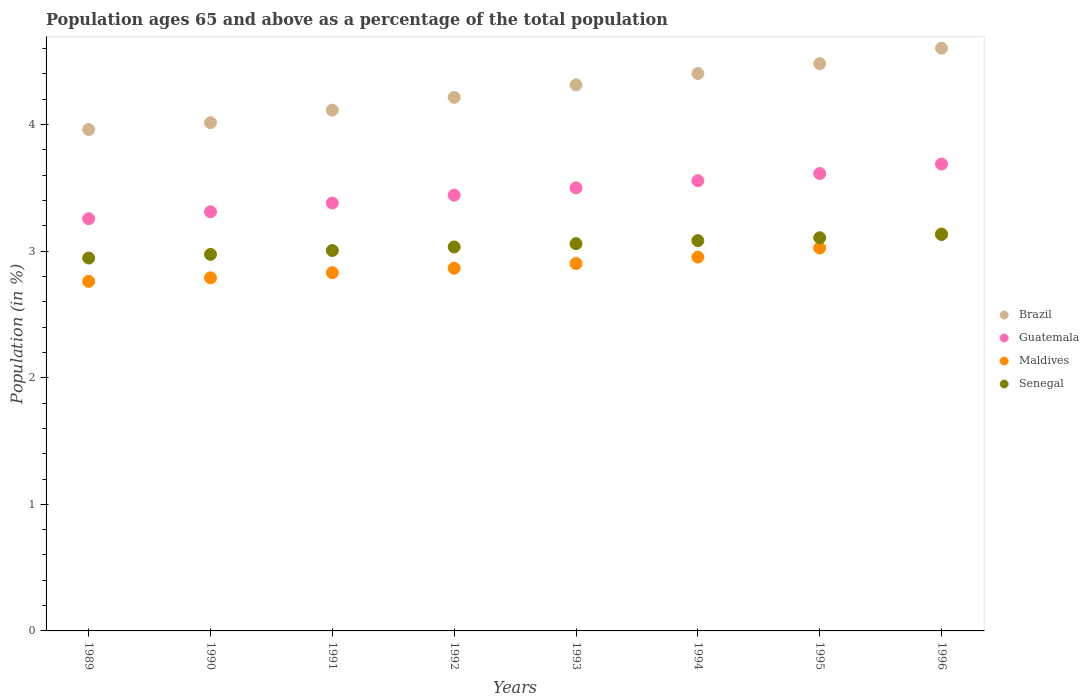Is the number of dotlines equal to the number of legend labels?
Offer a terse response. Yes. What is the percentage of the population ages 65 and above in Senegal in 1996?
Ensure brevity in your answer.  3.13. Across all years, what is the maximum percentage of the population ages 65 and above in Guatemala?
Ensure brevity in your answer.  3.69. Across all years, what is the minimum percentage of the population ages 65 and above in Brazil?
Ensure brevity in your answer.  3.96. What is the total percentage of the population ages 65 and above in Maldives in the graph?
Keep it short and to the point. 23.26. What is the difference between the percentage of the population ages 65 and above in Senegal in 1989 and that in 1991?
Offer a very short reply. -0.06. What is the difference between the percentage of the population ages 65 and above in Brazil in 1992 and the percentage of the population ages 65 and above in Senegal in 1995?
Give a very brief answer. 1.11. What is the average percentage of the population ages 65 and above in Guatemala per year?
Offer a very short reply. 3.47. In the year 1996, what is the difference between the percentage of the population ages 65 and above in Maldives and percentage of the population ages 65 and above in Brazil?
Provide a succinct answer. -1.47. In how many years, is the percentage of the population ages 65 and above in Guatemala greater than 0.8?
Your answer should be very brief. 8. What is the ratio of the percentage of the population ages 65 and above in Maldives in 1991 to that in 1993?
Your answer should be very brief. 0.98. Is the difference between the percentage of the population ages 65 and above in Maldives in 1993 and 1994 greater than the difference between the percentage of the population ages 65 and above in Brazil in 1993 and 1994?
Offer a terse response. Yes. What is the difference between the highest and the second highest percentage of the population ages 65 and above in Senegal?
Keep it short and to the point. 0.03. What is the difference between the highest and the lowest percentage of the population ages 65 and above in Maldives?
Give a very brief answer. 0.37. Is it the case that in every year, the sum of the percentage of the population ages 65 and above in Senegal and percentage of the population ages 65 and above in Maldives  is greater than the sum of percentage of the population ages 65 and above in Brazil and percentage of the population ages 65 and above in Guatemala?
Offer a terse response. No. Does the percentage of the population ages 65 and above in Guatemala monotonically increase over the years?
Provide a short and direct response. Yes. Is the percentage of the population ages 65 and above in Guatemala strictly greater than the percentage of the population ages 65 and above in Senegal over the years?
Provide a short and direct response. Yes. Does the graph contain any zero values?
Your answer should be very brief. No. Does the graph contain grids?
Your answer should be very brief. No. Where does the legend appear in the graph?
Ensure brevity in your answer.  Center right. What is the title of the graph?
Provide a succinct answer. Population ages 65 and above as a percentage of the total population. What is the label or title of the X-axis?
Your answer should be compact. Years. What is the label or title of the Y-axis?
Offer a very short reply. Population (in %). What is the Population (in %) of Brazil in 1989?
Offer a terse response. 3.96. What is the Population (in %) of Guatemala in 1989?
Your response must be concise. 3.26. What is the Population (in %) of Maldives in 1989?
Your answer should be very brief. 2.76. What is the Population (in %) in Senegal in 1989?
Give a very brief answer. 2.95. What is the Population (in %) in Brazil in 1990?
Your answer should be compact. 4.02. What is the Population (in %) in Guatemala in 1990?
Offer a very short reply. 3.31. What is the Population (in %) in Maldives in 1990?
Offer a terse response. 2.79. What is the Population (in %) of Senegal in 1990?
Give a very brief answer. 2.97. What is the Population (in %) in Brazil in 1991?
Make the answer very short. 4.11. What is the Population (in %) in Guatemala in 1991?
Your answer should be very brief. 3.38. What is the Population (in %) of Maldives in 1991?
Make the answer very short. 2.83. What is the Population (in %) of Senegal in 1991?
Your answer should be very brief. 3.01. What is the Population (in %) of Brazil in 1992?
Make the answer very short. 4.21. What is the Population (in %) of Guatemala in 1992?
Provide a succinct answer. 3.44. What is the Population (in %) in Maldives in 1992?
Your answer should be very brief. 2.87. What is the Population (in %) of Senegal in 1992?
Your response must be concise. 3.03. What is the Population (in %) in Brazil in 1993?
Offer a terse response. 4.31. What is the Population (in %) of Guatemala in 1993?
Provide a short and direct response. 3.5. What is the Population (in %) in Maldives in 1993?
Offer a terse response. 2.9. What is the Population (in %) in Senegal in 1993?
Provide a short and direct response. 3.06. What is the Population (in %) of Brazil in 1994?
Provide a succinct answer. 4.4. What is the Population (in %) of Guatemala in 1994?
Ensure brevity in your answer.  3.56. What is the Population (in %) in Maldives in 1994?
Your answer should be compact. 2.95. What is the Population (in %) of Senegal in 1994?
Give a very brief answer. 3.08. What is the Population (in %) in Brazil in 1995?
Provide a short and direct response. 4.48. What is the Population (in %) of Guatemala in 1995?
Ensure brevity in your answer.  3.61. What is the Population (in %) of Maldives in 1995?
Offer a terse response. 3.02. What is the Population (in %) in Senegal in 1995?
Provide a succinct answer. 3.11. What is the Population (in %) of Brazil in 1996?
Offer a very short reply. 4.6. What is the Population (in %) of Guatemala in 1996?
Ensure brevity in your answer.  3.69. What is the Population (in %) in Maldives in 1996?
Offer a very short reply. 3.14. What is the Population (in %) of Senegal in 1996?
Your response must be concise. 3.13. Across all years, what is the maximum Population (in %) in Brazil?
Your response must be concise. 4.6. Across all years, what is the maximum Population (in %) in Guatemala?
Your response must be concise. 3.69. Across all years, what is the maximum Population (in %) of Maldives?
Your answer should be compact. 3.14. Across all years, what is the maximum Population (in %) of Senegal?
Give a very brief answer. 3.13. Across all years, what is the minimum Population (in %) of Brazil?
Give a very brief answer. 3.96. Across all years, what is the minimum Population (in %) of Guatemala?
Give a very brief answer. 3.26. Across all years, what is the minimum Population (in %) of Maldives?
Your response must be concise. 2.76. Across all years, what is the minimum Population (in %) of Senegal?
Offer a very short reply. 2.95. What is the total Population (in %) in Brazil in the graph?
Offer a terse response. 34.11. What is the total Population (in %) in Guatemala in the graph?
Your answer should be compact. 27.75. What is the total Population (in %) in Maldives in the graph?
Make the answer very short. 23.26. What is the total Population (in %) in Senegal in the graph?
Make the answer very short. 24.34. What is the difference between the Population (in %) in Brazil in 1989 and that in 1990?
Your answer should be compact. -0.05. What is the difference between the Population (in %) in Guatemala in 1989 and that in 1990?
Your answer should be compact. -0.05. What is the difference between the Population (in %) of Maldives in 1989 and that in 1990?
Offer a very short reply. -0.03. What is the difference between the Population (in %) in Senegal in 1989 and that in 1990?
Make the answer very short. -0.03. What is the difference between the Population (in %) in Brazil in 1989 and that in 1991?
Your answer should be very brief. -0.15. What is the difference between the Population (in %) in Guatemala in 1989 and that in 1991?
Your response must be concise. -0.12. What is the difference between the Population (in %) in Maldives in 1989 and that in 1991?
Provide a short and direct response. -0.07. What is the difference between the Population (in %) of Senegal in 1989 and that in 1991?
Your response must be concise. -0.06. What is the difference between the Population (in %) of Brazil in 1989 and that in 1992?
Offer a very short reply. -0.25. What is the difference between the Population (in %) of Guatemala in 1989 and that in 1992?
Your answer should be very brief. -0.19. What is the difference between the Population (in %) in Maldives in 1989 and that in 1992?
Keep it short and to the point. -0.1. What is the difference between the Population (in %) of Senegal in 1989 and that in 1992?
Your response must be concise. -0.09. What is the difference between the Population (in %) in Brazil in 1989 and that in 1993?
Your response must be concise. -0.35. What is the difference between the Population (in %) of Guatemala in 1989 and that in 1993?
Your answer should be very brief. -0.24. What is the difference between the Population (in %) in Maldives in 1989 and that in 1993?
Make the answer very short. -0.14. What is the difference between the Population (in %) in Senegal in 1989 and that in 1993?
Your response must be concise. -0.11. What is the difference between the Population (in %) in Brazil in 1989 and that in 1994?
Provide a short and direct response. -0.44. What is the difference between the Population (in %) of Guatemala in 1989 and that in 1994?
Offer a terse response. -0.3. What is the difference between the Population (in %) of Maldives in 1989 and that in 1994?
Ensure brevity in your answer.  -0.19. What is the difference between the Population (in %) of Senegal in 1989 and that in 1994?
Provide a succinct answer. -0.14. What is the difference between the Population (in %) of Brazil in 1989 and that in 1995?
Give a very brief answer. -0.52. What is the difference between the Population (in %) in Guatemala in 1989 and that in 1995?
Your response must be concise. -0.36. What is the difference between the Population (in %) of Maldives in 1989 and that in 1995?
Offer a terse response. -0.26. What is the difference between the Population (in %) in Senegal in 1989 and that in 1995?
Your answer should be very brief. -0.16. What is the difference between the Population (in %) of Brazil in 1989 and that in 1996?
Your response must be concise. -0.64. What is the difference between the Population (in %) of Guatemala in 1989 and that in 1996?
Provide a succinct answer. -0.43. What is the difference between the Population (in %) in Maldives in 1989 and that in 1996?
Your answer should be very brief. -0.37. What is the difference between the Population (in %) of Senegal in 1989 and that in 1996?
Offer a terse response. -0.19. What is the difference between the Population (in %) of Brazil in 1990 and that in 1991?
Your answer should be very brief. -0.1. What is the difference between the Population (in %) in Guatemala in 1990 and that in 1991?
Offer a terse response. -0.07. What is the difference between the Population (in %) of Maldives in 1990 and that in 1991?
Give a very brief answer. -0.04. What is the difference between the Population (in %) in Senegal in 1990 and that in 1991?
Provide a succinct answer. -0.03. What is the difference between the Population (in %) in Brazil in 1990 and that in 1992?
Offer a very short reply. -0.2. What is the difference between the Population (in %) of Guatemala in 1990 and that in 1992?
Ensure brevity in your answer.  -0.13. What is the difference between the Population (in %) of Maldives in 1990 and that in 1992?
Offer a terse response. -0.08. What is the difference between the Population (in %) of Senegal in 1990 and that in 1992?
Make the answer very short. -0.06. What is the difference between the Population (in %) in Brazil in 1990 and that in 1993?
Provide a succinct answer. -0.3. What is the difference between the Population (in %) of Guatemala in 1990 and that in 1993?
Give a very brief answer. -0.19. What is the difference between the Population (in %) of Maldives in 1990 and that in 1993?
Ensure brevity in your answer.  -0.11. What is the difference between the Population (in %) of Senegal in 1990 and that in 1993?
Offer a very short reply. -0.08. What is the difference between the Population (in %) of Brazil in 1990 and that in 1994?
Your answer should be very brief. -0.39. What is the difference between the Population (in %) in Guatemala in 1990 and that in 1994?
Offer a very short reply. -0.24. What is the difference between the Population (in %) in Maldives in 1990 and that in 1994?
Keep it short and to the point. -0.16. What is the difference between the Population (in %) in Senegal in 1990 and that in 1994?
Offer a very short reply. -0.11. What is the difference between the Population (in %) in Brazil in 1990 and that in 1995?
Your answer should be very brief. -0.47. What is the difference between the Population (in %) of Guatemala in 1990 and that in 1995?
Provide a succinct answer. -0.3. What is the difference between the Population (in %) in Maldives in 1990 and that in 1995?
Give a very brief answer. -0.24. What is the difference between the Population (in %) of Senegal in 1990 and that in 1995?
Your response must be concise. -0.13. What is the difference between the Population (in %) in Brazil in 1990 and that in 1996?
Ensure brevity in your answer.  -0.59. What is the difference between the Population (in %) of Guatemala in 1990 and that in 1996?
Your answer should be compact. -0.38. What is the difference between the Population (in %) in Maldives in 1990 and that in 1996?
Ensure brevity in your answer.  -0.35. What is the difference between the Population (in %) in Senegal in 1990 and that in 1996?
Provide a succinct answer. -0.16. What is the difference between the Population (in %) in Brazil in 1991 and that in 1992?
Keep it short and to the point. -0.1. What is the difference between the Population (in %) of Guatemala in 1991 and that in 1992?
Provide a short and direct response. -0.06. What is the difference between the Population (in %) of Maldives in 1991 and that in 1992?
Ensure brevity in your answer.  -0.04. What is the difference between the Population (in %) of Senegal in 1991 and that in 1992?
Your answer should be very brief. -0.03. What is the difference between the Population (in %) in Brazil in 1991 and that in 1993?
Make the answer very short. -0.2. What is the difference between the Population (in %) in Guatemala in 1991 and that in 1993?
Your answer should be very brief. -0.12. What is the difference between the Population (in %) in Maldives in 1991 and that in 1993?
Your answer should be compact. -0.07. What is the difference between the Population (in %) of Senegal in 1991 and that in 1993?
Give a very brief answer. -0.05. What is the difference between the Population (in %) of Brazil in 1991 and that in 1994?
Offer a very short reply. -0.29. What is the difference between the Population (in %) in Guatemala in 1991 and that in 1994?
Make the answer very short. -0.18. What is the difference between the Population (in %) of Maldives in 1991 and that in 1994?
Give a very brief answer. -0.12. What is the difference between the Population (in %) of Senegal in 1991 and that in 1994?
Provide a succinct answer. -0.08. What is the difference between the Population (in %) in Brazil in 1991 and that in 1995?
Offer a very short reply. -0.37. What is the difference between the Population (in %) of Guatemala in 1991 and that in 1995?
Offer a very short reply. -0.23. What is the difference between the Population (in %) of Maldives in 1991 and that in 1995?
Make the answer very short. -0.19. What is the difference between the Population (in %) in Senegal in 1991 and that in 1995?
Offer a very short reply. -0.1. What is the difference between the Population (in %) of Brazil in 1991 and that in 1996?
Your response must be concise. -0.49. What is the difference between the Population (in %) of Guatemala in 1991 and that in 1996?
Your response must be concise. -0.31. What is the difference between the Population (in %) in Maldives in 1991 and that in 1996?
Keep it short and to the point. -0.31. What is the difference between the Population (in %) of Senegal in 1991 and that in 1996?
Your answer should be compact. -0.13. What is the difference between the Population (in %) in Brazil in 1992 and that in 1993?
Provide a succinct answer. -0.1. What is the difference between the Population (in %) of Guatemala in 1992 and that in 1993?
Your answer should be very brief. -0.06. What is the difference between the Population (in %) in Maldives in 1992 and that in 1993?
Your response must be concise. -0.04. What is the difference between the Population (in %) of Senegal in 1992 and that in 1993?
Offer a terse response. -0.03. What is the difference between the Population (in %) in Brazil in 1992 and that in 1994?
Keep it short and to the point. -0.19. What is the difference between the Population (in %) of Guatemala in 1992 and that in 1994?
Ensure brevity in your answer.  -0.11. What is the difference between the Population (in %) of Maldives in 1992 and that in 1994?
Ensure brevity in your answer.  -0.09. What is the difference between the Population (in %) in Senegal in 1992 and that in 1994?
Your answer should be compact. -0.05. What is the difference between the Population (in %) of Brazil in 1992 and that in 1995?
Provide a succinct answer. -0.27. What is the difference between the Population (in %) of Guatemala in 1992 and that in 1995?
Offer a terse response. -0.17. What is the difference between the Population (in %) of Maldives in 1992 and that in 1995?
Give a very brief answer. -0.16. What is the difference between the Population (in %) of Senegal in 1992 and that in 1995?
Offer a very short reply. -0.07. What is the difference between the Population (in %) of Brazil in 1992 and that in 1996?
Provide a short and direct response. -0.39. What is the difference between the Population (in %) of Guatemala in 1992 and that in 1996?
Provide a short and direct response. -0.25. What is the difference between the Population (in %) in Maldives in 1992 and that in 1996?
Offer a very short reply. -0.27. What is the difference between the Population (in %) in Senegal in 1992 and that in 1996?
Your answer should be very brief. -0.1. What is the difference between the Population (in %) of Brazil in 1993 and that in 1994?
Your response must be concise. -0.09. What is the difference between the Population (in %) in Guatemala in 1993 and that in 1994?
Your answer should be very brief. -0.06. What is the difference between the Population (in %) of Maldives in 1993 and that in 1994?
Offer a very short reply. -0.05. What is the difference between the Population (in %) in Senegal in 1993 and that in 1994?
Give a very brief answer. -0.02. What is the difference between the Population (in %) of Brazil in 1993 and that in 1995?
Your response must be concise. -0.17. What is the difference between the Population (in %) of Guatemala in 1993 and that in 1995?
Provide a short and direct response. -0.11. What is the difference between the Population (in %) of Maldives in 1993 and that in 1995?
Ensure brevity in your answer.  -0.12. What is the difference between the Population (in %) in Senegal in 1993 and that in 1995?
Give a very brief answer. -0.05. What is the difference between the Population (in %) in Brazil in 1993 and that in 1996?
Your answer should be very brief. -0.29. What is the difference between the Population (in %) in Guatemala in 1993 and that in 1996?
Your answer should be compact. -0.19. What is the difference between the Population (in %) of Maldives in 1993 and that in 1996?
Ensure brevity in your answer.  -0.23. What is the difference between the Population (in %) in Senegal in 1993 and that in 1996?
Offer a very short reply. -0.07. What is the difference between the Population (in %) in Brazil in 1994 and that in 1995?
Ensure brevity in your answer.  -0.08. What is the difference between the Population (in %) of Guatemala in 1994 and that in 1995?
Make the answer very short. -0.06. What is the difference between the Population (in %) in Maldives in 1994 and that in 1995?
Your answer should be very brief. -0.07. What is the difference between the Population (in %) of Senegal in 1994 and that in 1995?
Give a very brief answer. -0.02. What is the difference between the Population (in %) in Brazil in 1994 and that in 1996?
Make the answer very short. -0.2. What is the difference between the Population (in %) in Guatemala in 1994 and that in 1996?
Your answer should be very brief. -0.13. What is the difference between the Population (in %) of Maldives in 1994 and that in 1996?
Your answer should be compact. -0.18. What is the difference between the Population (in %) of Senegal in 1994 and that in 1996?
Give a very brief answer. -0.05. What is the difference between the Population (in %) of Brazil in 1995 and that in 1996?
Keep it short and to the point. -0.12. What is the difference between the Population (in %) of Guatemala in 1995 and that in 1996?
Keep it short and to the point. -0.07. What is the difference between the Population (in %) in Maldives in 1995 and that in 1996?
Offer a terse response. -0.11. What is the difference between the Population (in %) in Senegal in 1995 and that in 1996?
Provide a succinct answer. -0.03. What is the difference between the Population (in %) in Brazil in 1989 and the Population (in %) in Guatemala in 1990?
Your answer should be compact. 0.65. What is the difference between the Population (in %) in Brazil in 1989 and the Population (in %) in Maldives in 1990?
Provide a short and direct response. 1.17. What is the difference between the Population (in %) in Brazil in 1989 and the Population (in %) in Senegal in 1990?
Offer a very short reply. 0.99. What is the difference between the Population (in %) of Guatemala in 1989 and the Population (in %) of Maldives in 1990?
Offer a very short reply. 0.47. What is the difference between the Population (in %) of Guatemala in 1989 and the Population (in %) of Senegal in 1990?
Your answer should be very brief. 0.28. What is the difference between the Population (in %) in Maldives in 1989 and the Population (in %) in Senegal in 1990?
Provide a short and direct response. -0.21. What is the difference between the Population (in %) in Brazil in 1989 and the Population (in %) in Guatemala in 1991?
Keep it short and to the point. 0.58. What is the difference between the Population (in %) of Brazil in 1989 and the Population (in %) of Maldives in 1991?
Your response must be concise. 1.13. What is the difference between the Population (in %) in Brazil in 1989 and the Population (in %) in Senegal in 1991?
Provide a succinct answer. 0.96. What is the difference between the Population (in %) in Guatemala in 1989 and the Population (in %) in Maldives in 1991?
Your answer should be compact. 0.43. What is the difference between the Population (in %) of Guatemala in 1989 and the Population (in %) of Senegal in 1991?
Make the answer very short. 0.25. What is the difference between the Population (in %) of Maldives in 1989 and the Population (in %) of Senegal in 1991?
Your response must be concise. -0.24. What is the difference between the Population (in %) in Brazil in 1989 and the Population (in %) in Guatemala in 1992?
Make the answer very short. 0.52. What is the difference between the Population (in %) in Brazil in 1989 and the Population (in %) in Maldives in 1992?
Your answer should be very brief. 1.1. What is the difference between the Population (in %) of Brazil in 1989 and the Population (in %) of Senegal in 1992?
Your response must be concise. 0.93. What is the difference between the Population (in %) in Guatemala in 1989 and the Population (in %) in Maldives in 1992?
Provide a succinct answer. 0.39. What is the difference between the Population (in %) of Guatemala in 1989 and the Population (in %) of Senegal in 1992?
Your answer should be very brief. 0.22. What is the difference between the Population (in %) of Maldives in 1989 and the Population (in %) of Senegal in 1992?
Keep it short and to the point. -0.27. What is the difference between the Population (in %) of Brazil in 1989 and the Population (in %) of Guatemala in 1993?
Offer a very short reply. 0.46. What is the difference between the Population (in %) of Brazil in 1989 and the Population (in %) of Maldives in 1993?
Ensure brevity in your answer.  1.06. What is the difference between the Population (in %) in Brazil in 1989 and the Population (in %) in Senegal in 1993?
Keep it short and to the point. 0.9. What is the difference between the Population (in %) of Guatemala in 1989 and the Population (in %) of Maldives in 1993?
Your answer should be very brief. 0.35. What is the difference between the Population (in %) of Guatemala in 1989 and the Population (in %) of Senegal in 1993?
Make the answer very short. 0.2. What is the difference between the Population (in %) in Maldives in 1989 and the Population (in %) in Senegal in 1993?
Your answer should be very brief. -0.3. What is the difference between the Population (in %) in Brazil in 1989 and the Population (in %) in Guatemala in 1994?
Make the answer very short. 0.4. What is the difference between the Population (in %) of Brazil in 1989 and the Population (in %) of Maldives in 1994?
Keep it short and to the point. 1.01. What is the difference between the Population (in %) in Brazil in 1989 and the Population (in %) in Senegal in 1994?
Provide a succinct answer. 0.88. What is the difference between the Population (in %) of Guatemala in 1989 and the Population (in %) of Maldives in 1994?
Make the answer very short. 0.3. What is the difference between the Population (in %) in Guatemala in 1989 and the Population (in %) in Senegal in 1994?
Keep it short and to the point. 0.17. What is the difference between the Population (in %) in Maldives in 1989 and the Population (in %) in Senegal in 1994?
Your response must be concise. -0.32. What is the difference between the Population (in %) of Brazil in 1989 and the Population (in %) of Guatemala in 1995?
Give a very brief answer. 0.35. What is the difference between the Population (in %) of Brazil in 1989 and the Population (in %) of Maldives in 1995?
Give a very brief answer. 0.94. What is the difference between the Population (in %) in Brazil in 1989 and the Population (in %) in Senegal in 1995?
Provide a succinct answer. 0.86. What is the difference between the Population (in %) of Guatemala in 1989 and the Population (in %) of Maldives in 1995?
Provide a succinct answer. 0.23. What is the difference between the Population (in %) in Guatemala in 1989 and the Population (in %) in Senegal in 1995?
Keep it short and to the point. 0.15. What is the difference between the Population (in %) of Maldives in 1989 and the Population (in %) of Senegal in 1995?
Provide a short and direct response. -0.34. What is the difference between the Population (in %) of Brazil in 1989 and the Population (in %) of Guatemala in 1996?
Give a very brief answer. 0.27. What is the difference between the Population (in %) in Brazil in 1989 and the Population (in %) in Maldives in 1996?
Provide a short and direct response. 0.82. What is the difference between the Population (in %) of Brazil in 1989 and the Population (in %) of Senegal in 1996?
Your answer should be compact. 0.83. What is the difference between the Population (in %) of Guatemala in 1989 and the Population (in %) of Maldives in 1996?
Keep it short and to the point. 0.12. What is the difference between the Population (in %) of Guatemala in 1989 and the Population (in %) of Senegal in 1996?
Make the answer very short. 0.13. What is the difference between the Population (in %) in Maldives in 1989 and the Population (in %) in Senegal in 1996?
Offer a very short reply. -0.37. What is the difference between the Population (in %) of Brazil in 1990 and the Population (in %) of Guatemala in 1991?
Keep it short and to the point. 0.64. What is the difference between the Population (in %) in Brazil in 1990 and the Population (in %) in Maldives in 1991?
Ensure brevity in your answer.  1.19. What is the difference between the Population (in %) in Brazil in 1990 and the Population (in %) in Senegal in 1991?
Your answer should be compact. 1.01. What is the difference between the Population (in %) of Guatemala in 1990 and the Population (in %) of Maldives in 1991?
Keep it short and to the point. 0.48. What is the difference between the Population (in %) of Guatemala in 1990 and the Population (in %) of Senegal in 1991?
Ensure brevity in your answer.  0.31. What is the difference between the Population (in %) in Maldives in 1990 and the Population (in %) in Senegal in 1991?
Give a very brief answer. -0.22. What is the difference between the Population (in %) of Brazil in 1990 and the Population (in %) of Guatemala in 1992?
Provide a short and direct response. 0.57. What is the difference between the Population (in %) in Brazil in 1990 and the Population (in %) in Maldives in 1992?
Give a very brief answer. 1.15. What is the difference between the Population (in %) in Brazil in 1990 and the Population (in %) in Senegal in 1992?
Provide a short and direct response. 0.98. What is the difference between the Population (in %) of Guatemala in 1990 and the Population (in %) of Maldives in 1992?
Make the answer very short. 0.45. What is the difference between the Population (in %) of Guatemala in 1990 and the Population (in %) of Senegal in 1992?
Offer a very short reply. 0.28. What is the difference between the Population (in %) of Maldives in 1990 and the Population (in %) of Senegal in 1992?
Offer a very short reply. -0.24. What is the difference between the Population (in %) of Brazil in 1990 and the Population (in %) of Guatemala in 1993?
Ensure brevity in your answer.  0.52. What is the difference between the Population (in %) of Brazil in 1990 and the Population (in %) of Maldives in 1993?
Provide a succinct answer. 1.11. What is the difference between the Population (in %) of Brazil in 1990 and the Population (in %) of Senegal in 1993?
Offer a terse response. 0.96. What is the difference between the Population (in %) in Guatemala in 1990 and the Population (in %) in Maldives in 1993?
Your response must be concise. 0.41. What is the difference between the Population (in %) of Guatemala in 1990 and the Population (in %) of Senegal in 1993?
Keep it short and to the point. 0.25. What is the difference between the Population (in %) of Maldives in 1990 and the Population (in %) of Senegal in 1993?
Provide a succinct answer. -0.27. What is the difference between the Population (in %) in Brazil in 1990 and the Population (in %) in Guatemala in 1994?
Offer a terse response. 0.46. What is the difference between the Population (in %) in Brazil in 1990 and the Population (in %) in Maldives in 1994?
Provide a short and direct response. 1.06. What is the difference between the Population (in %) of Brazil in 1990 and the Population (in %) of Senegal in 1994?
Offer a terse response. 0.93. What is the difference between the Population (in %) of Guatemala in 1990 and the Population (in %) of Maldives in 1994?
Your answer should be compact. 0.36. What is the difference between the Population (in %) in Guatemala in 1990 and the Population (in %) in Senegal in 1994?
Offer a very short reply. 0.23. What is the difference between the Population (in %) in Maldives in 1990 and the Population (in %) in Senegal in 1994?
Make the answer very short. -0.29. What is the difference between the Population (in %) in Brazil in 1990 and the Population (in %) in Guatemala in 1995?
Make the answer very short. 0.4. What is the difference between the Population (in %) of Brazil in 1990 and the Population (in %) of Maldives in 1995?
Offer a terse response. 0.99. What is the difference between the Population (in %) in Brazil in 1990 and the Population (in %) in Senegal in 1995?
Your answer should be compact. 0.91. What is the difference between the Population (in %) of Guatemala in 1990 and the Population (in %) of Maldives in 1995?
Keep it short and to the point. 0.29. What is the difference between the Population (in %) of Guatemala in 1990 and the Population (in %) of Senegal in 1995?
Your answer should be very brief. 0.21. What is the difference between the Population (in %) of Maldives in 1990 and the Population (in %) of Senegal in 1995?
Your answer should be very brief. -0.32. What is the difference between the Population (in %) in Brazil in 1990 and the Population (in %) in Guatemala in 1996?
Your answer should be compact. 0.33. What is the difference between the Population (in %) in Brazil in 1990 and the Population (in %) in Maldives in 1996?
Provide a succinct answer. 0.88. What is the difference between the Population (in %) of Brazil in 1990 and the Population (in %) of Senegal in 1996?
Your answer should be very brief. 0.88. What is the difference between the Population (in %) of Guatemala in 1990 and the Population (in %) of Maldives in 1996?
Offer a very short reply. 0.18. What is the difference between the Population (in %) of Guatemala in 1990 and the Population (in %) of Senegal in 1996?
Offer a terse response. 0.18. What is the difference between the Population (in %) in Maldives in 1990 and the Population (in %) in Senegal in 1996?
Your answer should be compact. -0.34. What is the difference between the Population (in %) in Brazil in 1991 and the Population (in %) in Guatemala in 1992?
Your answer should be compact. 0.67. What is the difference between the Population (in %) of Brazil in 1991 and the Population (in %) of Maldives in 1992?
Make the answer very short. 1.25. What is the difference between the Population (in %) of Brazil in 1991 and the Population (in %) of Senegal in 1992?
Your answer should be very brief. 1.08. What is the difference between the Population (in %) in Guatemala in 1991 and the Population (in %) in Maldives in 1992?
Ensure brevity in your answer.  0.52. What is the difference between the Population (in %) of Guatemala in 1991 and the Population (in %) of Senegal in 1992?
Offer a terse response. 0.35. What is the difference between the Population (in %) of Maldives in 1991 and the Population (in %) of Senegal in 1992?
Offer a terse response. -0.2. What is the difference between the Population (in %) in Brazil in 1991 and the Population (in %) in Guatemala in 1993?
Offer a terse response. 0.61. What is the difference between the Population (in %) in Brazil in 1991 and the Population (in %) in Maldives in 1993?
Offer a very short reply. 1.21. What is the difference between the Population (in %) of Brazil in 1991 and the Population (in %) of Senegal in 1993?
Offer a very short reply. 1.05. What is the difference between the Population (in %) of Guatemala in 1991 and the Population (in %) of Maldives in 1993?
Provide a succinct answer. 0.48. What is the difference between the Population (in %) in Guatemala in 1991 and the Population (in %) in Senegal in 1993?
Provide a succinct answer. 0.32. What is the difference between the Population (in %) of Maldives in 1991 and the Population (in %) of Senegal in 1993?
Ensure brevity in your answer.  -0.23. What is the difference between the Population (in %) in Brazil in 1991 and the Population (in %) in Guatemala in 1994?
Ensure brevity in your answer.  0.56. What is the difference between the Population (in %) of Brazil in 1991 and the Population (in %) of Maldives in 1994?
Offer a terse response. 1.16. What is the difference between the Population (in %) in Brazil in 1991 and the Population (in %) in Senegal in 1994?
Your response must be concise. 1.03. What is the difference between the Population (in %) in Guatemala in 1991 and the Population (in %) in Maldives in 1994?
Offer a very short reply. 0.43. What is the difference between the Population (in %) of Guatemala in 1991 and the Population (in %) of Senegal in 1994?
Provide a succinct answer. 0.3. What is the difference between the Population (in %) of Maldives in 1991 and the Population (in %) of Senegal in 1994?
Your answer should be compact. -0.25. What is the difference between the Population (in %) of Brazil in 1991 and the Population (in %) of Guatemala in 1995?
Keep it short and to the point. 0.5. What is the difference between the Population (in %) in Brazil in 1991 and the Population (in %) in Maldives in 1995?
Offer a terse response. 1.09. What is the difference between the Population (in %) of Brazil in 1991 and the Population (in %) of Senegal in 1995?
Your response must be concise. 1.01. What is the difference between the Population (in %) in Guatemala in 1991 and the Population (in %) in Maldives in 1995?
Your answer should be very brief. 0.36. What is the difference between the Population (in %) in Guatemala in 1991 and the Population (in %) in Senegal in 1995?
Your answer should be compact. 0.27. What is the difference between the Population (in %) in Maldives in 1991 and the Population (in %) in Senegal in 1995?
Offer a very short reply. -0.28. What is the difference between the Population (in %) of Brazil in 1991 and the Population (in %) of Guatemala in 1996?
Your answer should be very brief. 0.43. What is the difference between the Population (in %) of Brazil in 1991 and the Population (in %) of Maldives in 1996?
Provide a succinct answer. 0.98. What is the difference between the Population (in %) of Brazil in 1991 and the Population (in %) of Senegal in 1996?
Offer a very short reply. 0.98. What is the difference between the Population (in %) in Guatemala in 1991 and the Population (in %) in Maldives in 1996?
Offer a terse response. 0.24. What is the difference between the Population (in %) of Guatemala in 1991 and the Population (in %) of Senegal in 1996?
Your answer should be compact. 0.25. What is the difference between the Population (in %) in Maldives in 1991 and the Population (in %) in Senegal in 1996?
Provide a short and direct response. -0.3. What is the difference between the Population (in %) in Brazil in 1992 and the Population (in %) in Guatemala in 1993?
Make the answer very short. 0.72. What is the difference between the Population (in %) in Brazil in 1992 and the Population (in %) in Maldives in 1993?
Offer a very short reply. 1.31. What is the difference between the Population (in %) in Brazil in 1992 and the Population (in %) in Senegal in 1993?
Your answer should be compact. 1.16. What is the difference between the Population (in %) of Guatemala in 1992 and the Population (in %) of Maldives in 1993?
Offer a terse response. 0.54. What is the difference between the Population (in %) in Guatemala in 1992 and the Population (in %) in Senegal in 1993?
Your answer should be compact. 0.38. What is the difference between the Population (in %) in Maldives in 1992 and the Population (in %) in Senegal in 1993?
Keep it short and to the point. -0.19. What is the difference between the Population (in %) of Brazil in 1992 and the Population (in %) of Guatemala in 1994?
Your response must be concise. 0.66. What is the difference between the Population (in %) in Brazil in 1992 and the Population (in %) in Maldives in 1994?
Your response must be concise. 1.26. What is the difference between the Population (in %) of Brazil in 1992 and the Population (in %) of Senegal in 1994?
Make the answer very short. 1.13. What is the difference between the Population (in %) of Guatemala in 1992 and the Population (in %) of Maldives in 1994?
Keep it short and to the point. 0.49. What is the difference between the Population (in %) in Guatemala in 1992 and the Population (in %) in Senegal in 1994?
Your answer should be very brief. 0.36. What is the difference between the Population (in %) of Maldives in 1992 and the Population (in %) of Senegal in 1994?
Your response must be concise. -0.22. What is the difference between the Population (in %) of Brazil in 1992 and the Population (in %) of Guatemala in 1995?
Make the answer very short. 0.6. What is the difference between the Population (in %) of Brazil in 1992 and the Population (in %) of Maldives in 1995?
Your answer should be very brief. 1.19. What is the difference between the Population (in %) in Brazil in 1992 and the Population (in %) in Senegal in 1995?
Offer a terse response. 1.11. What is the difference between the Population (in %) in Guatemala in 1992 and the Population (in %) in Maldives in 1995?
Your answer should be very brief. 0.42. What is the difference between the Population (in %) in Guatemala in 1992 and the Population (in %) in Senegal in 1995?
Give a very brief answer. 0.34. What is the difference between the Population (in %) of Maldives in 1992 and the Population (in %) of Senegal in 1995?
Offer a very short reply. -0.24. What is the difference between the Population (in %) in Brazil in 1992 and the Population (in %) in Guatemala in 1996?
Your response must be concise. 0.53. What is the difference between the Population (in %) in Brazil in 1992 and the Population (in %) in Maldives in 1996?
Ensure brevity in your answer.  1.08. What is the difference between the Population (in %) in Brazil in 1992 and the Population (in %) in Senegal in 1996?
Offer a terse response. 1.08. What is the difference between the Population (in %) of Guatemala in 1992 and the Population (in %) of Maldives in 1996?
Offer a terse response. 0.31. What is the difference between the Population (in %) of Guatemala in 1992 and the Population (in %) of Senegal in 1996?
Offer a very short reply. 0.31. What is the difference between the Population (in %) of Maldives in 1992 and the Population (in %) of Senegal in 1996?
Provide a short and direct response. -0.27. What is the difference between the Population (in %) of Brazil in 1993 and the Population (in %) of Guatemala in 1994?
Give a very brief answer. 0.76. What is the difference between the Population (in %) of Brazil in 1993 and the Population (in %) of Maldives in 1994?
Provide a short and direct response. 1.36. What is the difference between the Population (in %) of Brazil in 1993 and the Population (in %) of Senegal in 1994?
Make the answer very short. 1.23. What is the difference between the Population (in %) of Guatemala in 1993 and the Population (in %) of Maldives in 1994?
Give a very brief answer. 0.55. What is the difference between the Population (in %) in Guatemala in 1993 and the Population (in %) in Senegal in 1994?
Your answer should be very brief. 0.42. What is the difference between the Population (in %) of Maldives in 1993 and the Population (in %) of Senegal in 1994?
Ensure brevity in your answer.  -0.18. What is the difference between the Population (in %) in Brazil in 1993 and the Population (in %) in Guatemala in 1995?
Give a very brief answer. 0.7. What is the difference between the Population (in %) of Brazil in 1993 and the Population (in %) of Maldives in 1995?
Provide a succinct answer. 1.29. What is the difference between the Population (in %) in Brazil in 1993 and the Population (in %) in Senegal in 1995?
Keep it short and to the point. 1.21. What is the difference between the Population (in %) of Guatemala in 1993 and the Population (in %) of Maldives in 1995?
Provide a succinct answer. 0.47. What is the difference between the Population (in %) in Guatemala in 1993 and the Population (in %) in Senegal in 1995?
Your answer should be compact. 0.39. What is the difference between the Population (in %) in Maldives in 1993 and the Population (in %) in Senegal in 1995?
Provide a succinct answer. -0.2. What is the difference between the Population (in %) of Brazil in 1993 and the Population (in %) of Guatemala in 1996?
Make the answer very short. 0.63. What is the difference between the Population (in %) in Brazil in 1993 and the Population (in %) in Maldives in 1996?
Ensure brevity in your answer.  1.18. What is the difference between the Population (in %) in Brazil in 1993 and the Population (in %) in Senegal in 1996?
Make the answer very short. 1.18. What is the difference between the Population (in %) of Guatemala in 1993 and the Population (in %) of Maldives in 1996?
Keep it short and to the point. 0.36. What is the difference between the Population (in %) of Guatemala in 1993 and the Population (in %) of Senegal in 1996?
Your answer should be compact. 0.37. What is the difference between the Population (in %) of Maldives in 1993 and the Population (in %) of Senegal in 1996?
Provide a succinct answer. -0.23. What is the difference between the Population (in %) of Brazil in 1994 and the Population (in %) of Guatemala in 1995?
Provide a short and direct response. 0.79. What is the difference between the Population (in %) in Brazil in 1994 and the Population (in %) in Maldives in 1995?
Keep it short and to the point. 1.38. What is the difference between the Population (in %) of Brazil in 1994 and the Population (in %) of Senegal in 1995?
Offer a terse response. 1.3. What is the difference between the Population (in %) in Guatemala in 1994 and the Population (in %) in Maldives in 1995?
Offer a very short reply. 0.53. What is the difference between the Population (in %) in Guatemala in 1994 and the Population (in %) in Senegal in 1995?
Offer a terse response. 0.45. What is the difference between the Population (in %) of Maldives in 1994 and the Population (in %) of Senegal in 1995?
Your answer should be very brief. -0.15. What is the difference between the Population (in %) of Brazil in 1994 and the Population (in %) of Guatemala in 1996?
Provide a succinct answer. 0.72. What is the difference between the Population (in %) in Brazil in 1994 and the Population (in %) in Maldives in 1996?
Ensure brevity in your answer.  1.27. What is the difference between the Population (in %) of Brazil in 1994 and the Population (in %) of Senegal in 1996?
Your answer should be very brief. 1.27. What is the difference between the Population (in %) in Guatemala in 1994 and the Population (in %) in Maldives in 1996?
Make the answer very short. 0.42. What is the difference between the Population (in %) in Guatemala in 1994 and the Population (in %) in Senegal in 1996?
Give a very brief answer. 0.43. What is the difference between the Population (in %) in Maldives in 1994 and the Population (in %) in Senegal in 1996?
Your answer should be very brief. -0.18. What is the difference between the Population (in %) of Brazil in 1995 and the Population (in %) of Guatemala in 1996?
Your response must be concise. 0.79. What is the difference between the Population (in %) in Brazil in 1995 and the Population (in %) in Maldives in 1996?
Provide a short and direct response. 1.34. What is the difference between the Population (in %) of Brazil in 1995 and the Population (in %) of Senegal in 1996?
Give a very brief answer. 1.35. What is the difference between the Population (in %) of Guatemala in 1995 and the Population (in %) of Maldives in 1996?
Provide a short and direct response. 0.48. What is the difference between the Population (in %) of Guatemala in 1995 and the Population (in %) of Senegal in 1996?
Keep it short and to the point. 0.48. What is the difference between the Population (in %) in Maldives in 1995 and the Population (in %) in Senegal in 1996?
Your answer should be very brief. -0.11. What is the average Population (in %) in Brazil per year?
Your response must be concise. 4.26. What is the average Population (in %) of Guatemala per year?
Give a very brief answer. 3.47. What is the average Population (in %) in Maldives per year?
Offer a terse response. 2.91. What is the average Population (in %) in Senegal per year?
Ensure brevity in your answer.  3.04. In the year 1989, what is the difference between the Population (in %) of Brazil and Population (in %) of Guatemala?
Offer a terse response. 0.7. In the year 1989, what is the difference between the Population (in %) in Brazil and Population (in %) in Maldives?
Offer a terse response. 1.2. In the year 1989, what is the difference between the Population (in %) in Brazil and Population (in %) in Senegal?
Provide a succinct answer. 1.02. In the year 1989, what is the difference between the Population (in %) of Guatemala and Population (in %) of Maldives?
Your answer should be very brief. 0.5. In the year 1989, what is the difference between the Population (in %) in Guatemala and Population (in %) in Senegal?
Ensure brevity in your answer.  0.31. In the year 1989, what is the difference between the Population (in %) in Maldives and Population (in %) in Senegal?
Your answer should be compact. -0.18. In the year 1990, what is the difference between the Population (in %) of Brazil and Population (in %) of Guatemala?
Offer a terse response. 0.7. In the year 1990, what is the difference between the Population (in %) in Brazil and Population (in %) in Maldives?
Offer a terse response. 1.23. In the year 1990, what is the difference between the Population (in %) of Brazil and Population (in %) of Senegal?
Your answer should be compact. 1.04. In the year 1990, what is the difference between the Population (in %) in Guatemala and Population (in %) in Maldives?
Provide a short and direct response. 0.52. In the year 1990, what is the difference between the Population (in %) in Guatemala and Population (in %) in Senegal?
Ensure brevity in your answer.  0.34. In the year 1990, what is the difference between the Population (in %) in Maldives and Population (in %) in Senegal?
Offer a very short reply. -0.19. In the year 1991, what is the difference between the Population (in %) of Brazil and Population (in %) of Guatemala?
Offer a very short reply. 0.73. In the year 1991, what is the difference between the Population (in %) of Brazil and Population (in %) of Maldives?
Your answer should be compact. 1.28. In the year 1991, what is the difference between the Population (in %) in Brazil and Population (in %) in Senegal?
Keep it short and to the point. 1.11. In the year 1991, what is the difference between the Population (in %) in Guatemala and Population (in %) in Maldives?
Your response must be concise. 0.55. In the year 1991, what is the difference between the Population (in %) in Guatemala and Population (in %) in Senegal?
Keep it short and to the point. 0.38. In the year 1991, what is the difference between the Population (in %) of Maldives and Population (in %) of Senegal?
Keep it short and to the point. -0.18. In the year 1992, what is the difference between the Population (in %) in Brazil and Population (in %) in Guatemala?
Your answer should be very brief. 0.77. In the year 1992, what is the difference between the Population (in %) of Brazil and Population (in %) of Maldives?
Ensure brevity in your answer.  1.35. In the year 1992, what is the difference between the Population (in %) in Brazil and Population (in %) in Senegal?
Provide a short and direct response. 1.18. In the year 1992, what is the difference between the Population (in %) in Guatemala and Population (in %) in Maldives?
Your answer should be very brief. 0.58. In the year 1992, what is the difference between the Population (in %) of Guatemala and Population (in %) of Senegal?
Make the answer very short. 0.41. In the year 1992, what is the difference between the Population (in %) of Maldives and Population (in %) of Senegal?
Give a very brief answer. -0.17. In the year 1993, what is the difference between the Population (in %) in Brazil and Population (in %) in Guatemala?
Give a very brief answer. 0.81. In the year 1993, what is the difference between the Population (in %) in Brazil and Population (in %) in Maldives?
Provide a succinct answer. 1.41. In the year 1993, what is the difference between the Population (in %) in Brazil and Population (in %) in Senegal?
Offer a very short reply. 1.25. In the year 1993, what is the difference between the Population (in %) of Guatemala and Population (in %) of Maldives?
Provide a short and direct response. 0.6. In the year 1993, what is the difference between the Population (in %) of Guatemala and Population (in %) of Senegal?
Offer a very short reply. 0.44. In the year 1993, what is the difference between the Population (in %) of Maldives and Population (in %) of Senegal?
Your response must be concise. -0.16. In the year 1994, what is the difference between the Population (in %) of Brazil and Population (in %) of Guatemala?
Ensure brevity in your answer.  0.85. In the year 1994, what is the difference between the Population (in %) in Brazil and Population (in %) in Maldives?
Offer a terse response. 1.45. In the year 1994, what is the difference between the Population (in %) in Brazil and Population (in %) in Senegal?
Ensure brevity in your answer.  1.32. In the year 1994, what is the difference between the Population (in %) of Guatemala and Population (in %) of Maldives?
Keep it short and to the point. 0.6. In the year 1994, what is the difference between the Population (in %) of Guatemala and Population (in %) of Senegal?
Offer a very short reply. 0.47. In the year 1994, what is the difference between the Population (in %) of Maldives and Population (in %) of Senegal?
Ensure brevity in your answer.  -0.13. In the year 1995, what is the difference between the Population (in %) in Brazil and Population (in %) in Guatemala?
Make the answer very short. 0.87. In the year 1995, what is the difference between the Population (in %) of Brazil and Population (in %) of Maldives?
Provide a succinct answer. 1.46. In the year 1995, what is the difference between the Population (in %) of Brazil and Population (in %) of Senegal?
Provide a succinct answer. 1.38. In the year 1995, what is the difference between the Population (in %) in Guatemala and Population (in %) in Maldives?
Offer a very short reply. 0.59. In the year 1995, what is the difference between the Population (in %) in Guatemala and Population (in %) in Senegal?
Ensure brevity in your answer.  0.51. In the year 1995, what is the difference between the Population (in %) in Maldives and Population (in %) in Senegal?
Your response must be concise. -0.08. In the year 1996, what is the difference between the Population (in %) in Brazil and Population (in %) in Guatemala?
Make the answer very short. 0.91. In the year 1996, what is the difference between the Population (in %) in Brazil and Population (in %) in Maldives?
Provide a short and direct response. 1.47. In the year 1996, what is the difference between the Population (in %) in Brazil and Population (in %) in Senegal?
Provide a succinct answer. 1.47. In the year 1996, what is the difference between the Population (in %) of Guatemala and Population (in %) of Maldives?
Provide a short and direct response. 0.55. In the year 1996, what is the difference between the Population (in %) of Guatemala and Population (in %) of Senegal?
Ensure brevity in your answer.  0.56. In the year 1996, what is the difference between the Population (in %) of Maldives and Population (in %) of Senegal?
Offer a very short reply. 0.01. What is the ratio of the Population (in %) in Brazil in 1989 to that in 1990?
Your answer should be compact. 0.99. What is the ratio of the Population (in %) of Guatemala in 1989 to that in 1990?
Provide a short and direct response. 0.98. What is the ratio of the Population (in %) of Maldives in 1989 to that in 1990?
Make the answer very short. 0.99. What is the ratio of the Population (in %) in Senegal in 1989 to that in 1990?
Offer a very short reply. 0.99. What is the ratio of the Population (in %) of Brazil in 1989 to that in 1991?
Ensure brevity in your answer.  0.96. What is the ratio of the Population (in %) of Guatemala in 1989 to that in 1991?
Make the answer very short. 0.96. What is the ratio of the Population (in %) of Maldives in 1989 to that in 1991?
Give a very brief answer. 0.98. What is the ratio of the Population (in %) of Senegal in 1989 to that in 1991?
Your response must be concise. 0.98. What is the ratio of the Population (in %) in Brazil in 1989 to that in 1992?
Make the answer very short. 0.94. What is the ratio of the Population (in %) of Guatemala in 1989 to that in 1992?
Ensure brevity in your answer.  0.95. What is the ratio of the Population (in %) of Maldives in 1989 to that in 1992?
Provide a succinct answer. 0.96. What is the ratio of the Population (in %) of Senegal in 1989 to that in 1992?
Make the answer very short. 0.97. What is the ratio of the Population (in %) in Brazil in 1989 to that in 1993?
Make the answer very short. 0.92. What is the ratio of the Population (in %) of Guatemala in 1989 to that in 1993?
Your answer should be compact. 0.93. What is the ratio of the Population (in %) in Maldives in 1989 to that in 1993?
Keep it short and to the point. 0.95. What is the ratio of the Population (in %) in Senegal in 1989 to that in 1993?
Your answer should be very brief. 0.96. What is the ratio of the Population (in %) of Brazil in 1989 to that in 1994?
Your answer should be very brief. 0.9. What is the ratio of the Population (in %) in Guatemala in 1989 to that in 1994?
Provide a succinct answer. 0.92. What is the ratio of the Population (in %) of Maldives in 1989 to that in 1994?
Give a very brief answer. 0.94. What is the ratio of the Population (in %) of Senegal in 1989 to that in 1994?
Your response must be concise. 0.96. What is the ratio of the Population (in %) of Brazil in 1989 to that in 1995?
Give a very brief answer. 0.88. What is the ratio of the Population (in %) of Guatemala in 1989 to that in 1995?
Your response must be concise. 0.9. What is the ratio of the Population (in %) in Maldives in 1989 to that in 1995?
Provide a succinct answer. 0.91. What is the ratio of the Population (in %) of Senegal in 1989 to that in 1995?
Your answer should be very brief. 0.95. What is the ratio of the Population (in %) of Brazil in 1989 to that in 1996?
Your answer should be compact. 0.86. What is the ratio of the Population (in %) of Guatemala in 1989 to that in 1996?
Provide a short and direct response. 0.88. What is the ratio of the Population (in %) in Maldives in 1989 to that in 1996?
Provide a succinct answer. 0.88. What is the ratio of the Population (in %) in Senegal in 1989 to that in 1996?
Offer a terse response. 0.94. What is the ratio of the Population (in %) of Guatemala in 1990 to that in 1991?
Keep it short and to the point. 0.98. What is the ratio of the Population (in %) in Maldives in 1990 to that in 1991?
Keep it short and to the point. 0.99. What is the ratio of the Population (in %) in Brazil in 1990 to that in 1992?
Give a very brief answer. 0.95. What is the ratio of the Population (in %) in Maldives in 1990 to that in 1992?
Offer a terse response. 0.97. What is the ratio of the Population (in %) in Senegal in 1990 to that in 1992?
Keep it short and to the point. 0.98. What is the ratio of the Population (in %) in Brazil in 1990 to that in 1993?
Your response must be concise. 0.93. What is the ratio of the Population (in %) in Guatemala in 1990 to that in 1993?
Your answer should be very brief. 0.95. What is the ratio of the Population (in %) in Maldives in 1990 to that in 1993?
Provide a succinct answer. 0.96. What is the ratio of the Population (in %) in Senegal in 1990 to that in 1993?
Your answer should be compact. 0.97. What is the ratio of the Population (in %) in Brazil in 1990 to that in 1994?
Your answer should be compact. 0.91. What is the ratio of the Population (in %) in Guatemala in 1990 to that in 1994?
Give a very brief answer. 0.93. What is the ratio of the Population (in %) of Maldives in 1990 to that in 1994?
Give a very brief answer. 0.94. What is the ratio of the Population (in %) of Senegal in 1990 to that in 1994?
Offer a terse response. 0.96. What is the ratio of the Population (in %) in Brazil in 1990 to that in 1995?
Ensure brevity in your answer.  0.9. What is the ratio of the Population (in %) in Guatemala in 1990 to that in 1995?
Provide a succinct answer. 0.92. What is the ratio of the Population (in %) of Maldives in 1990 to that in 1995?
Give a very brief answer. 0.92. What is the ratio of the Population (in %) of Senegal in 1990 to that in 1995?
Your answer should be very brief. 0.96. What is the ratio of the Population (in %) in Brazil in 1990 to that in 1996?
Provide a short and direct response. 0.87. What is the ratio of the Population (in %) of Guatemala in 1990 to that in 1996?
Offer a terse response. 0.9. What is the ratio of the Population (in %) of Maldives in 1990 to that in 1996?
Your answer should be very brief. 0.89. What is the ratio of the Population (in %) in Senegal in 1990 to that in 1996?
Provide a succinct answer. 0.95. What is the ratio of the Population (in %) of Brazil in 1991 to that in 1992?
Your answer should be compact. 0.98. What is the ratio of the Population (in %) of Maldives in 1991 to that in 1992?
Make the answer very short. 0.99. What is the ratio of the Population (in %) of Senegal in 1991 to that in 1992?
Ensure brevity in your answer.  0.99. What is the ratio of the Population (in %) of Brazil in 1991 to that in 1993?
Ensure brevity in your answer.  0.95. What is the ratio of the Population (in %) in Guatemala in 1991 to that in 1993?
Make the answer very short. 0.97. What is the ratio of the Population (in %) in Maldives in 1991 to that in 1993?
Make the answer very short. 0.98. What is the ratio of the Population (in %) in Senegal in 1991 to that in 1993?
Offer a very short reply. 0.98. What is the ratio of the Population (in %) of Brazil in 1991 to that in 1994?
Offer a terse response. 0.93. What is the ratio of the Population (in %) in Guatemala in 1991 to that in 1994?
Give a very brief answer. 0.95. What is the ratio of the Population (in %) in Maldives in 1991 to that in 1994?
Keep it short and to the point. 0.96. What is the ratio of the Population (in %) of Senegal in 1991 to that in 1994?
Provide a succinct answer. 0.97. What is the ratio of the Population (in %) of Brazil in 1991 to that in 1995?
Keep it short and to the point. 0.92. What is the ratio of the Population (in %) of Guatemala in 1991 to that in 1995?
Give a very brief answer. 0.94. What is the ratio of the Population (in %) of Maldives in 1991 to that in 1995?
Your answer should be compact. 0.94. What is the ratio of the Population (in %) of Senegal in 1991 to that in 1995?
Your answer should be very brief. 0.97. What is the ratio of the Population (in %) of Brazil in 1991 to that in 1996?
Make the answer very short. 0.89. What is the ratio of the Population (in %) in Guatemala in 1991 to that in 1996?
Provide a succinct answer. 0.92. What is the ratio of the Population (in %) of Maldives in 1991 to that in 1996?
Give a very brief answer. 0.9. What is the ratio of the Population (in %) in Senegal in 1991 to that in 1996?
Offer a very short reply. 0.96. What is the ratio of the Population (in %) in Brazil in 1992 to that in 1993?
Offer a very short reply. 0.98. What is the ratio of the Population (in %) of Guatemala in 1992 to that in 1993?
Keep it short and to the point. 0.98. What is the ratio of the Population (in %) in Maldives in 1992 to that in 1993?
Provide a short and direct response. 0.99. What is the ratio of the Population (in %) of Brazil in 1992 to that in 1994?
Provide a short and direct response. 0.96. What is the ratio of the Population (in %) of Guatemala in 1992 to that in 1994?
Offer a terse response. 0.97. What is the ratio of the Population (in %) of Maldives in 1992 to that in 1994?
Ensure brevity in your answer.  0.97. What is the ratio of the Population (in %) in Senegal in 1992 to that in 1994?
Provide a short and direct response. 0.98. What is the ratio of the Population (in %) in Brazil in 1992 to that in 1995?
Your answer should be very brief. 0.94. What is the ratio of the Population (in %) in Guatemala in 1992 to that in 1995?
Your answer should be compact. 0.95. What is the ratio of the Population (in %) of Maldives in 1992 to that in 1995?
Make the answer very short. 0.95. What is the ratio of the Population (in %) in Senegal in 1992 to that in 1995?
Your response must be concise. 0.98. What is the ratio of the Population (in %) in Brazil in 1992 to that in 1996?
Ensure brevity in your answer.  0.92. What is the ratio of the Population (in %) of Guatemala in 1992 to that in 1996?
Your answer should be very brief. 0.93. What is the ratio of the Population (in %) in Maldives in 1992 to that in 1996?
Your answer should be very brief. 0.91. What is the ratio of the Population (in %) of Senegal in 1992 to that in 1996?
Give a very brief answer. 0.97. What is the ratio of the Population (in %) in Brazil in 1993 to that in 1994?
Provide a short and direct response. 0.98. What is the ratio of the Population (in %) of Guatemala in 1993 to that in 1994?
Keep it short and to the point. 0.98. What is the ratio of the Population (in %) of Maldives in 1993 to that in 1994?
Provide a succinct answer. 0.98. What is the ratio of the Population (in %) in Senegal in 1993 to that in 1994?
Offer a terse response. 0.99. What is the ratio of the Population (in %) of Brazil in 1993 to that in 1995?
Provide a succinct answer. 0.96. What is the ratio of the Population (in %) of Guatemala in 1993 to that in 1995?
Your answer should be very brief. 0.97. What is the ratio of the Population (in %) of Maldives in 1993 to that in 1995?
Your response must be concise. 0.96. What is the ratio of the Population (in %) in Senegal in 1993 to that in 1995?
Your response must be concise. 0.98. What is the ratio of the Population (in %) of Brazil in 1993 to that in 1996?
Ensure brevity in your answer.  0.94. What is the ratio of the Population (in %) in Guatemala in 1993 to that in 1996?
Your answer should be compact. 0.95. What is the ratio of the Population (in %) in Maldives in 1993 to that in 1996?
Your response must be concise. 0.93. What is the ratio of the Population (in %) in Senegal in 1993 to that in 1996?
Keep it short and to the point. 0.98. What is the ratio of the Population (in %) of Brazil in 1994 to that in 1995?
Your response must be concise. 0.98. What is the ratio of the Population (in %) of Guatemala in 1994 to that in 1995?
Your answer should be very brief. 0.98. What is the ratio of the Population (in %) in Maldives in 1994 to that in 1995?
Keep it short and to the point. 0.98. What is the ratio of the Population (in %) in Senegal in 1994 to that in 1995?
Your response must be concise. 0.99. What is the ratio of the Population (in %) of Brazil in 1994 to that in 1996?
Your answer should be compact. 0.96. What is the ratio of the Population (in %) of Guatemala in 1994 to that in 1996?
Offer a very short reply. 0.96. What is the ratio of the Population (in %) of Maldives in 1994 to that in 1996?
Make the answer very short. 0.94. What is the ratio of the Population (in %) of Senegal in 1994 to that in 1996?
Your answer should be compact. 0.98. What is the ratio of the Population (in %) in Brazil in 1995 to that in 1996?
Ensure brevity in your answer.  0.97. What is the ratio of the Population (in %) of Guatemala in 1995 to that in 1996?
Your answer should be very brief. 0.98. What is the ratio of the Population (in %) of Maldives in 1995 to that in 1996?
Ensure brevity in your answer.  0.96. What is the difference between the highest and the second highest Population (in %) in Brazil?
Provide a succinct answer. 0.12. What is the difference between the highest and the second highest Population (in %) of Guatemala?
Your response must be concise. 0.07. What is the difference between the highest and the second highest Population (in %) in Maldives?
Provide a succinct answer. 0.11. What is the difference between the highest and the second highest Population (in %) in Senegal?
Make the answer very short. 0.03. What is the difference between the highest and the lowest Population (in %) in Brazil?
Offer a very short reply. 0.64. What is the difference between the highest and the lowest Population (in %) of Guatemala?
Ensure brevity in your answer.  0.43. What is the difference between the highest and the lowest Population (in %) of Maldives?
Provide a succinct answer. 0.37. What is the difference between the highest and the lowest Population (in %) of Senegal?
Offer a very short reply. 0.19. 